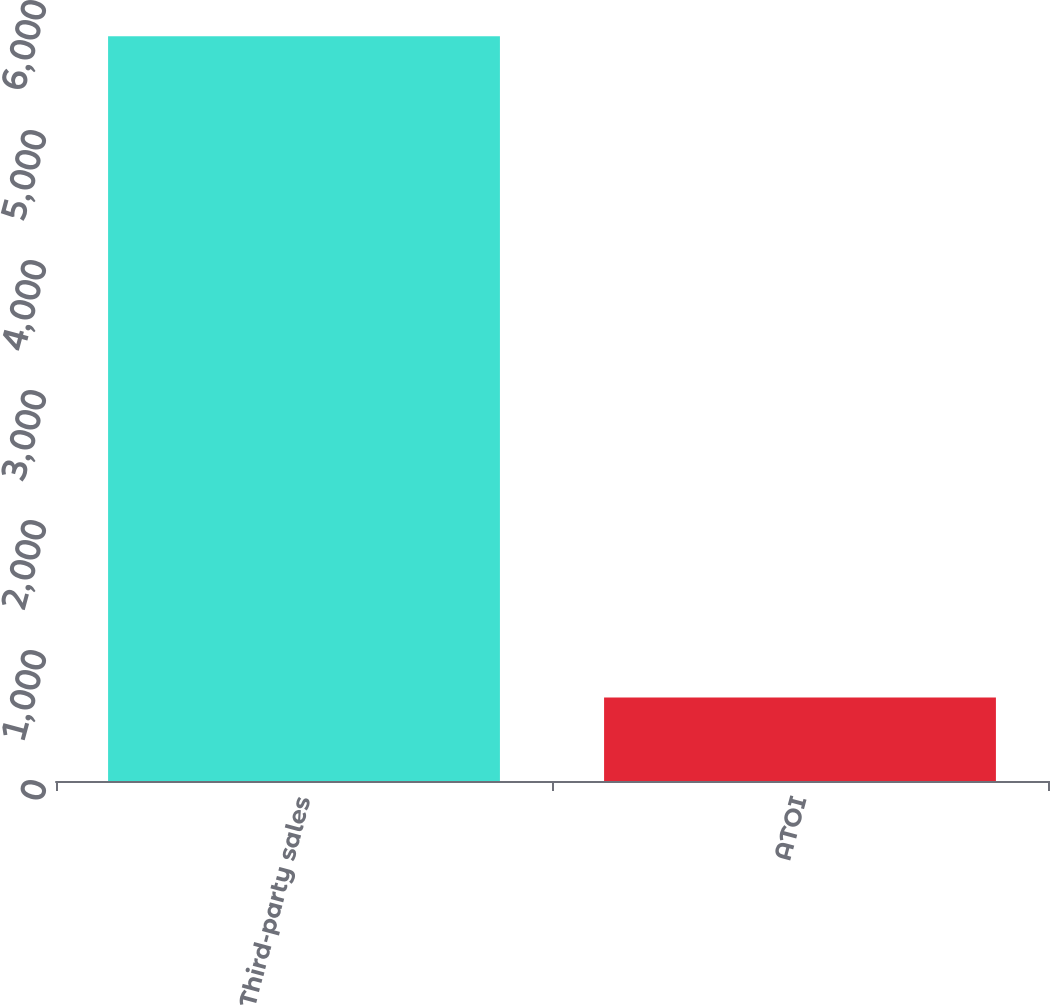Convert chart to OTSL. <chart><loc_0><loc_0><loc_500><loc_500><bar_chart><fcel>Third-party sales<fcel>ATOI<nl><fcel>5728<fcel>642<nl></chart> 